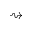Convert formula to latex. <formula><loc_0><loc_0><loc_500><loc_500>\right s q u i g a r r o w</formula> 